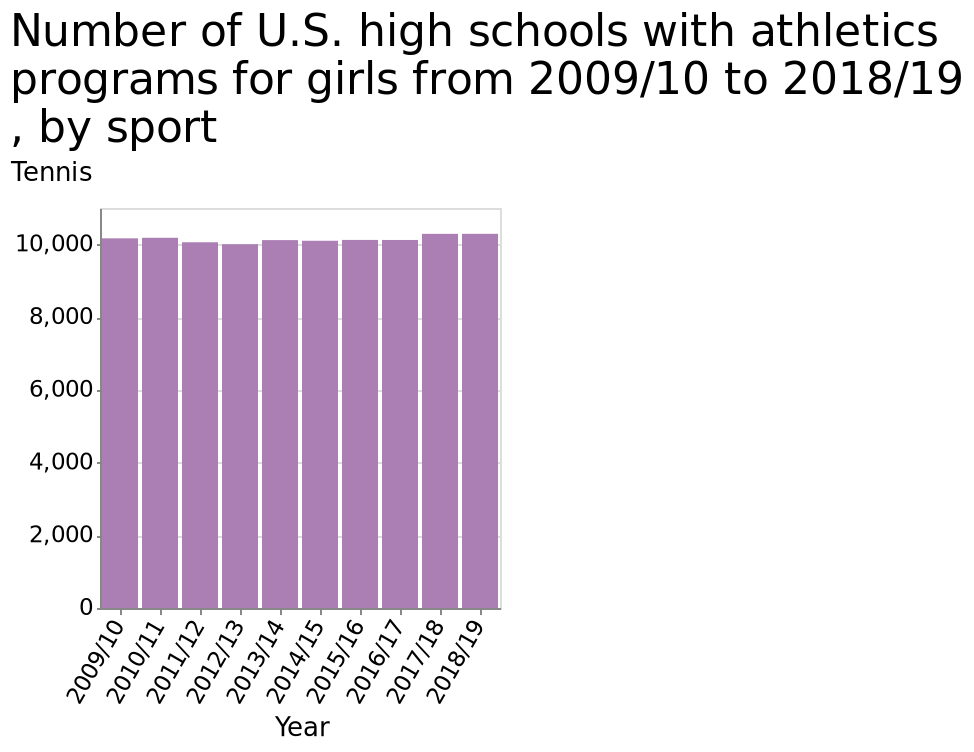<image>
What does the x-axis represent in the bar graph?  The x-axis in the bar graph represents the years from 2009/10 to 2018/19. 